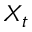Convert formula to latex. <formula><loc_0><loc_0><loc_500><loc_500>X _ { t }</formula> 